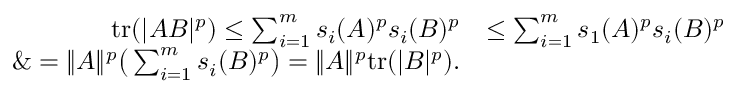<formula> <loc_0><loc_0><loc_500><loc_500>\begin{array} { r l } { t r ( | A B | ^ { p } ) \leq \sum _ { i = 1 } ^ { m } s _ { i } ( A ) ^ { p } s _ { i } ( B ) ^ { p } } & { \leq \sum _ { i = 1 } ^ { m } s _ { 1 } ( A ) ^ { p } s _ { i } ( B ) ^ { p } } \\ { \& = \| A \| ^ { p } \left ( \sum _ { i = 1 } ^ { m } s _ { i } ( B ) ^ { p } \right ) = \| A \| ^ { p } t r ( | B | ^ { p } ) . } \end{array}</formula> 